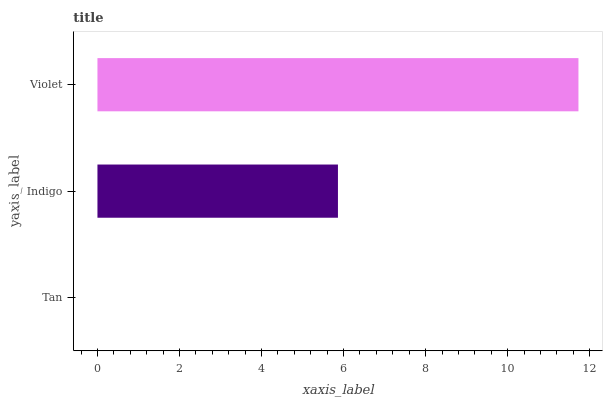Is Tan the minimum?
Answer yes or no. Yes. Is Violet the maximum?
Answer yes or no. Yes. Is Indigo the minimum?
Answer yes or no. No. Is Indigo the maximum?
Answer yes or no. No. Is Indigo greater than Tan?
Answer yes or no. Yes. Is Tan less than Indigo?
Answer yes or no. Yes. Is Tan greater than Indigo?
Answer yes or no. No. Is Indigo less than Tan?
Answer yes or no. No. Is Indigo the high median?
Answer yes or no. Yes. Is Indigo the low median?
Answer yes or no. Yes. Is Violet the high median?
Answer yes or no. No. Is Violet the low median?
Answer yes or no. No. 